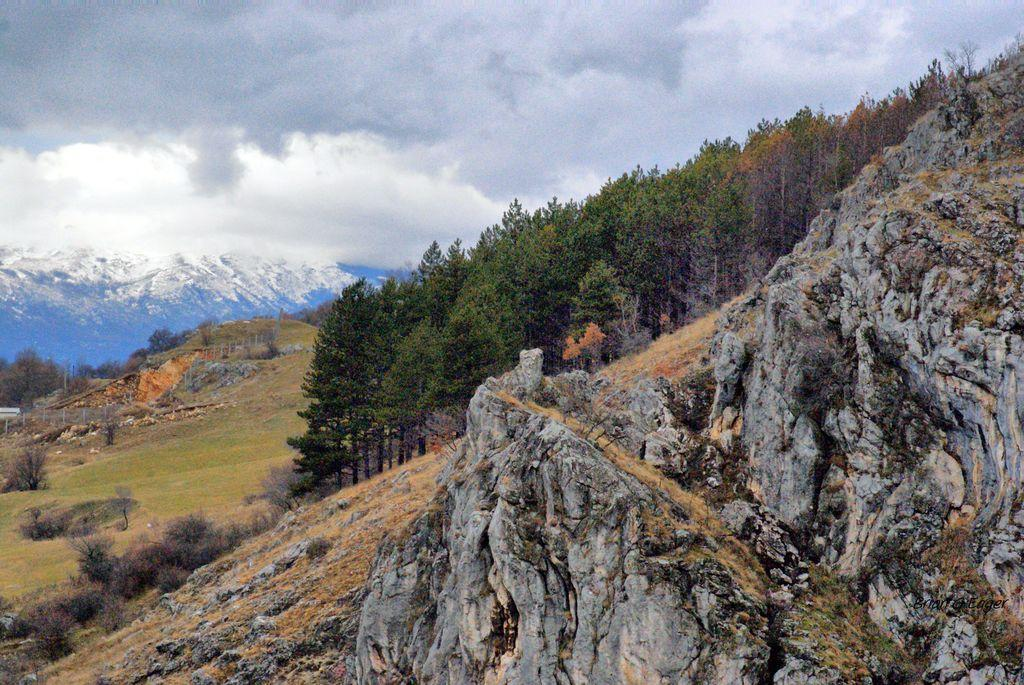What type of vegetation is on the right side of the image? There are trees and plants on the right side of the image. What other natural features can be seen on the right side of the image? There are rocks on a mountain on the right side of the image. What can be seen in the background of the image? There are trees, grass, and a mountain in the background of the image, along with clouds in the sky. What type of horn is visible on the mountain in the image? There is no horn visible on the mountain in the image. What color is the skin of the trees in the image? Trees do not have skin, so this question cannot be answered. 